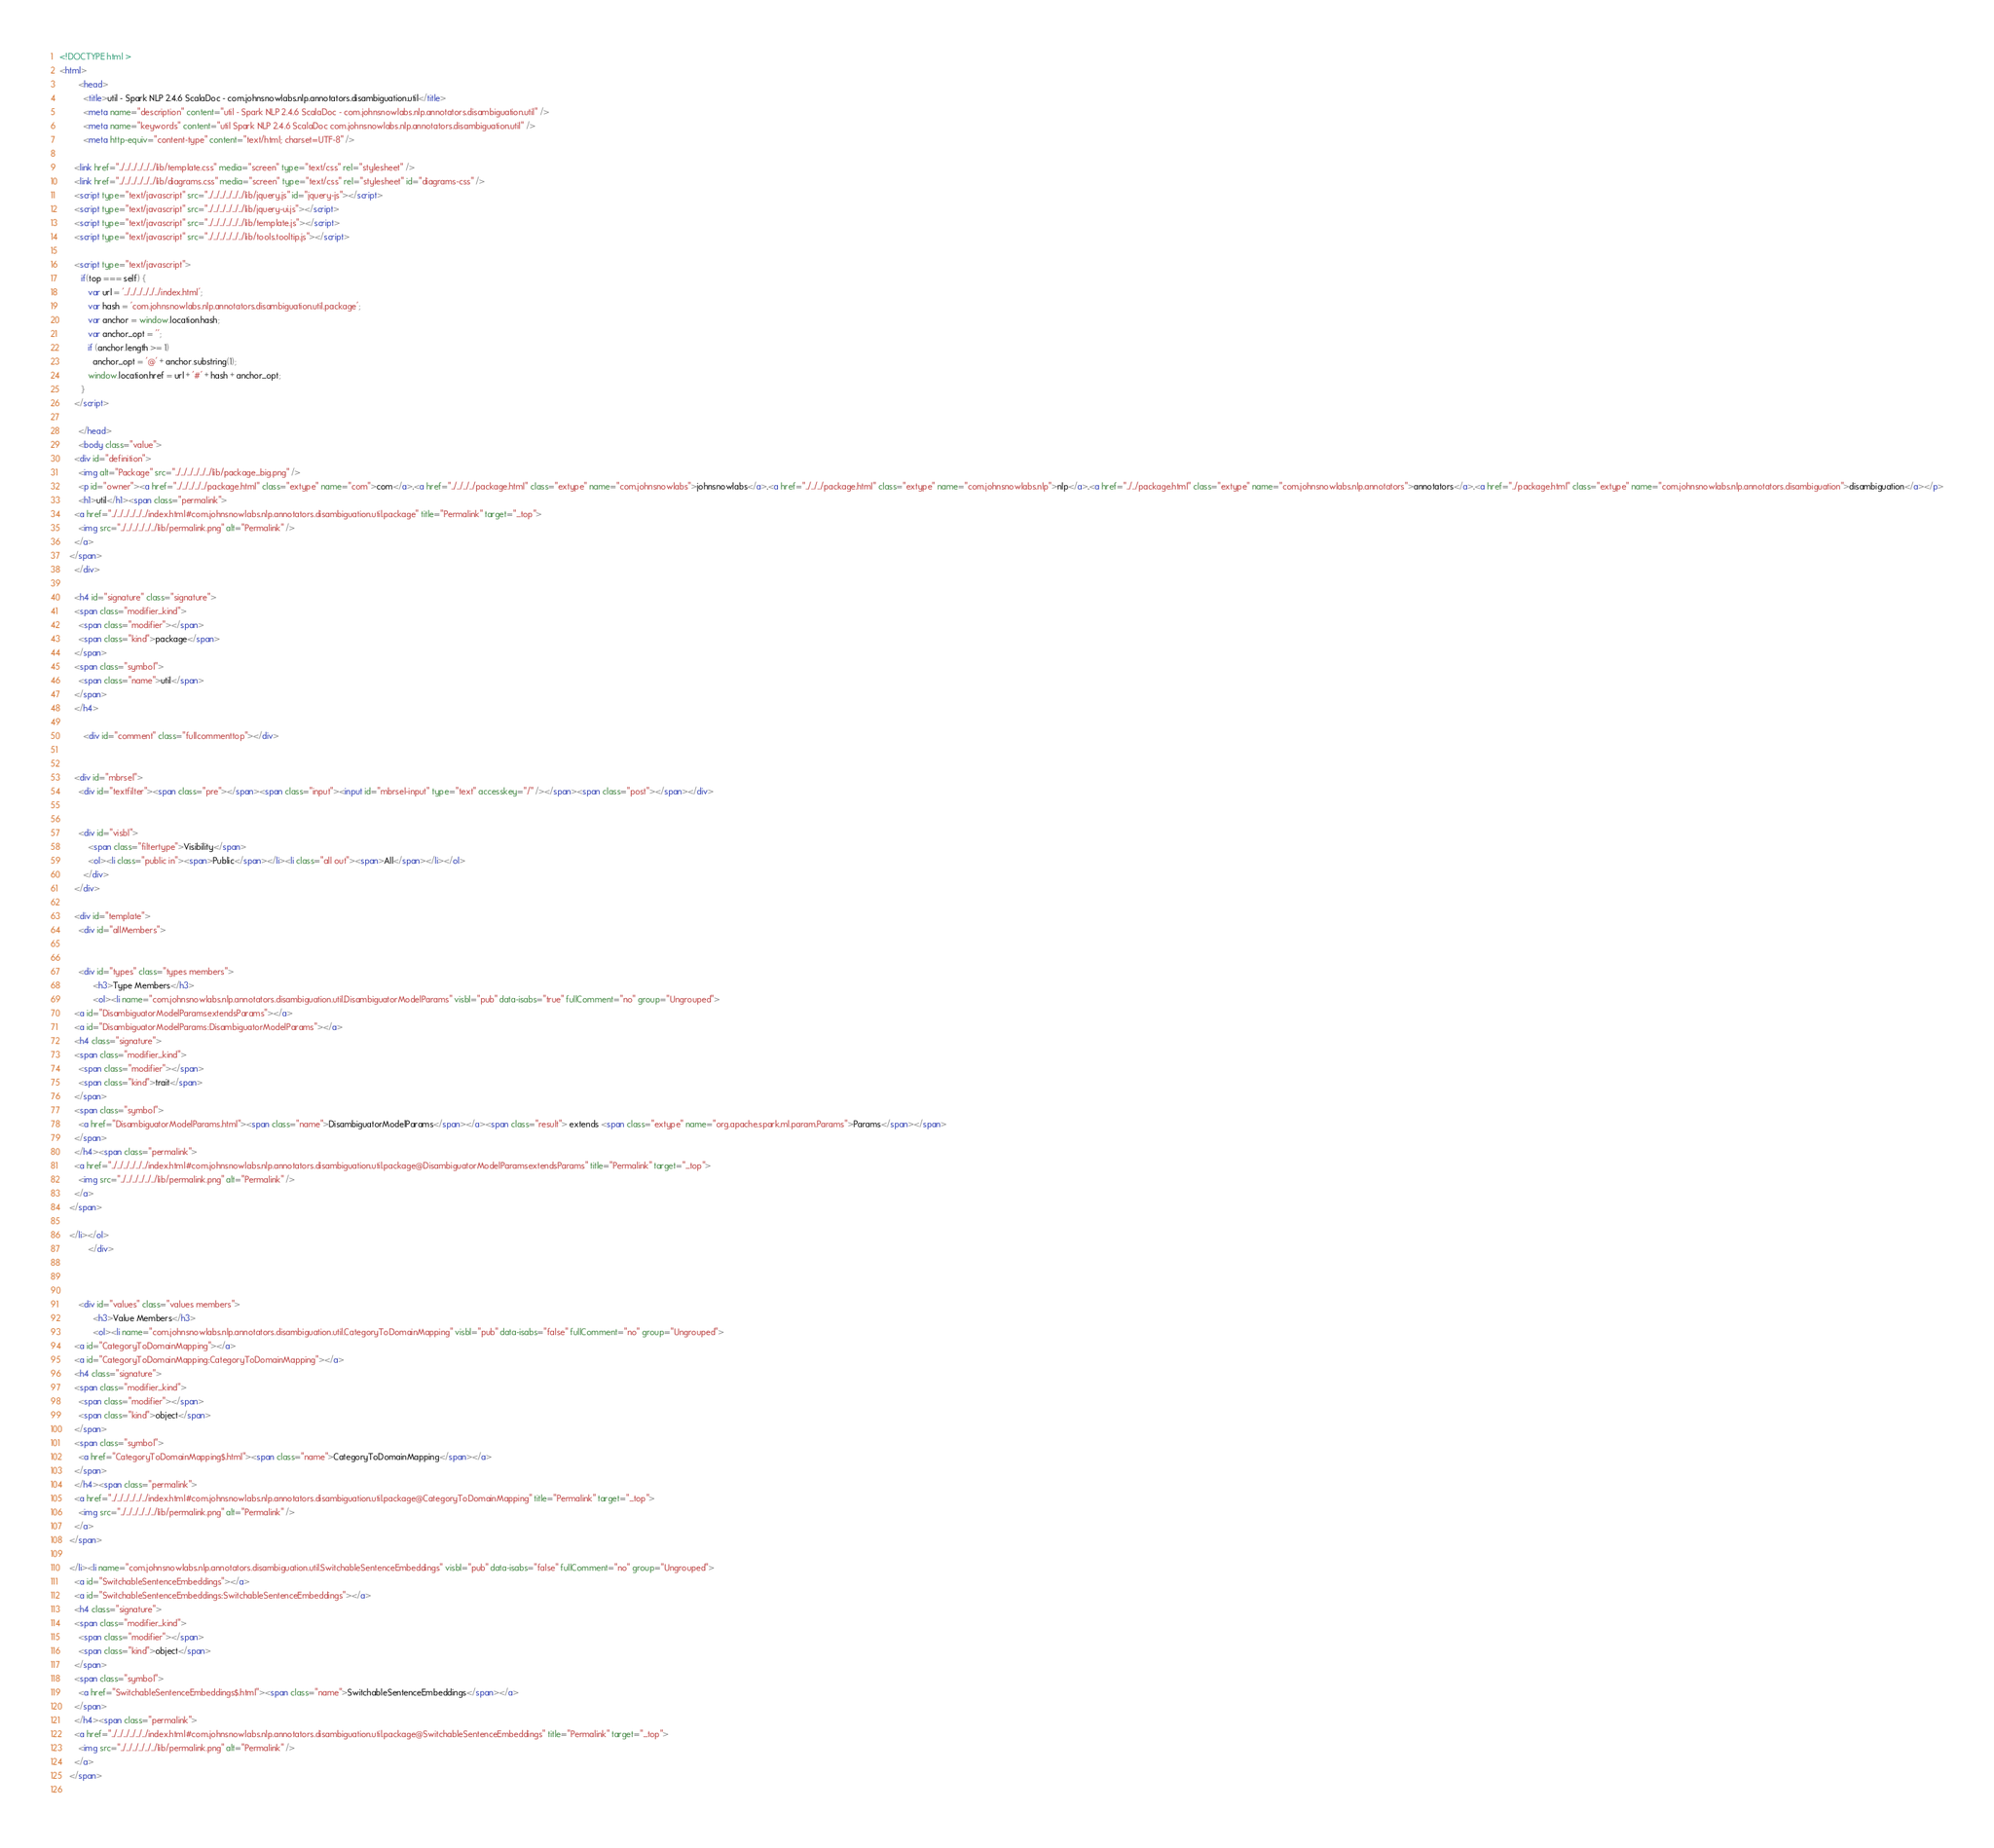<code> <loc_0><loc_0><loc_500><loc_500><_HTML_><!DOCTYPE html >
<html>
        <head>
          <title>util - Spark NLP 2.4.6 ScalaDoc - com.johnsnowlabs.nlp.annotators.disambiguation.util</title>
          <meta name="description" content="util - Spark NLP 2.4.6 ScalaDoc - com.johnsnowlabs.nlp.annotators.disambiguation.util" />
          <meta name="keywords" content="util Spark NLP 2.4.6 ScalaDoc com.johnsnowlabs.nlp.annotators.disambiguation.util" />
          <meta http-equiv="content-type" content="text/html; charset=UTF-8" />
          
      <link href="../../../../../../lib/template.css" media="screen" type="text/css" rel="stylesheet" />
      <link href="../../../../../../lib/diagrams.css" media="screen" type="text/css" rel="stylesheet" id="diagrams-css" />
      <script type="text/javascript" src="../../../../../../lib/jquery.js" id="jquery-js"></script>
      <script type="text/javascript" src="../../../../../../lib/jquery-ui.js"></script>
      <script type="text/javascript" src="../../../../../../lib/template.js"></script>
      <script type="text/javascript" src="../../../../../../lib/tools.tooltip.js"></script>
      
      <script type="text/javascript">
         if(top === self) {
            var url = '../../../../../../index.html';
            var hash = 'com.johnsnowlabs.nlp.annotators.disambiguation.util.package';
            var anchor = window.location.hash;
            var anchor_opt = '';
            if (anchor.length >= 1)
              anchor_opt = '@' + anchor.substring(1);
            window.location.href = url + '#' + hash + anchor_opt;
         }
   	  </script>
    
        </head>
        <body class="value">
      <div id="definition">
        <img alt="Package" src="../../../../../../lib/package_big.png" />
        <p id="owner"><a href="../../../../../package.html" class="extype" name="com">com</a>.<a href="../../../../package.html" class="extype" name="com.johnsnowlabs">johnsnowlabs</a>.<a href="../../../package.html" class="extype" name="com.johnsnowlabs.nlp">nlp</a>.<a href="../../package.html" class="extype" name="com.johnsnowlabs.nlp.annotators">annotators</a>.<a href="../package.html" class="extype" name="com.johnsnowlabs.nlp.annotators.disambiguation">disambiguation</a></p>
        <h1>util</h1><span class="permalink">
      <a href="../../../../../../index.html#com.johnsnowlabs.nlp.annotators.disambiguation.util.package" title="Permalink" target="_top">
        <img src="../../../../../../lib/permalink.png" alt="Permalink" />
      </a>
    </span>
      </div>

      <h4 id="signature" class="signature">
      <span class="modifier_kind">
        <span class="modifier"></span>
        <span class="kind">package</span>
      </span>
      <span class="symbol">
        <span class="name">util</span>
      </span>
      </h4>
      
          <div id="comment" class="fullcommenttop"></div>
        

      <div id="mbrsel">
        <div id="textfilter"><span class="pre"></span><span class="input"><input id="mbrsel-input" type="text" accesskey="/" /></span><span class="post"></span></div>
        
        
        <div id="visbl">
            <span class="filtertype">Visibility</span>
            <ol><li class="public in"><span>Public</span></li><li class="all out"><span>All</span></li></ol>
          </div>
      </div>

      <div id="template">
        <div id="allMembers">
        

        <div id="types" class="types members">
              <h3>Type Members</h3>
              <ol><li name="com.johnsnowlabs.nlp.annotators.disambiguation.util.DisambiguatorModelParams" visbl="pub" data-isabs="true" fullComment="no" group="Ungrouped">
      <a id="DisambiguatorModelParamsextendsParams"></a>
      <a id="DisambiguatorModelParams:DisambiguatorModelParams"></a>
      <h4 class="signature">
      <span class="modifier_kind">
        <span class="modifier"></span>
        <span class="kind">trait</span>
      </span>
      <span class="symbol">
        <a href="DisambiguatorModelParams.html"><span class="name">DisambiguatorModelParams</span></a><span class="result"> extends <span class="extype" name="org.apache.spark.ml.param.Params">Params</span></span>
      </span>
      </h4><span class="permalink">
      <a href="../../../../../../index.html#com.johnsnowlabs.nlp.annotators.disambiguation.util.package@DisambiguatorModelParamsextendsParams" title="Permalink" target="_top">
        <img src="../../../../../../lib/permalink.png" alt="Permalink" />
      </a>
    </span>
      
    </li></ol>
            </div>

        

        <div id="values" class="values members">
              <h3>Value Members</h3>
              <ol><li name="com.johnsnowlabs.nlp.annotators.disambiguation.util.CategoryToDomainMapping" visbl="pub" data-isabs="false" fullComment="no" group="Ungrouped">
      <a id="CategoryToDomainMapping"></a>
      <a id="CategoryToDomainMapping:CategoryToDomainMapping"></a>
      <h4 class="signature">
      <span class="modifier_kind">
        <span class="modifier"></span>
        <span class="kind">object</span>
      </span>
      <span class="symbol">
        <a href="CategoryToDomainMapping$.html"><span class="name">CategoryToDomainMapping</span></a>
      </span>
      </h4><span class="permalink">
      <a href="../../../../../../index.html#com.johnsnowlabs.nlp.annotators.disambiguation.util.package@CategoryToDomainMapping" title="Permalink" target="_top">
        <img src="../../../../../../lib/permalink.png" alt="Permalink" />
      </a>
    </span>
      
    </li><li name="com.johnsnowlabs.nlp.annotators.disambiguation.util.SwitchableSentenceEmbeddings" visbl="pub" data-isabs="false" fullComment="no" group="Ungrouped">
      <a id="SwitchableSentenceEmbeddings"></a>
      <a id="SwitchableSentenceEmbeddings:SwitchableSentenceEmbeddings"></a>
      <h4 class="signature">
      <span class="modifier_kind">
        <span class="modifier"></span>
        <span class="kind">object</span>
      </span>
      <span class="symbol">
        <a href="SwitchableSentenceEmbeddings$.html"><span class="name">SwitchableSentenceEmbeddings</span></a>
      </span>
      </h4><span class="permalink">
      <a href="../../../../../../index.html#com.johnsnowlabs.nlp.annotators.disambiguation.util.package@SwitchableSentenceEmbeddings" title="Permalink" target="_top">
        <img src="../../../../../../lib/permalink.png" alt="Permalink" />
      </a>
    </span>
      </code> 